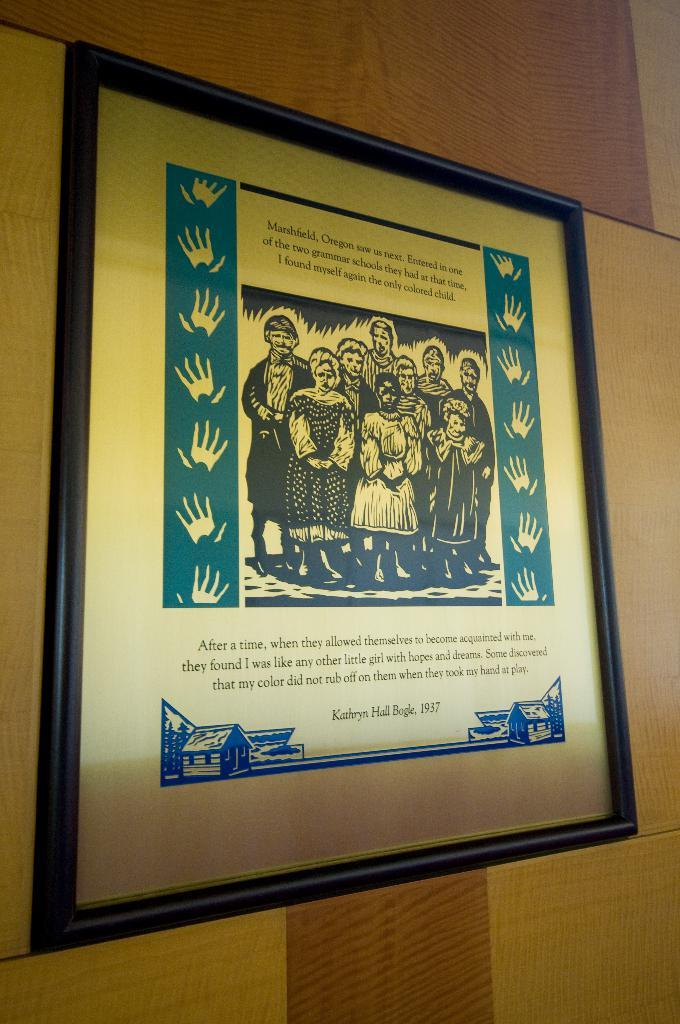Provide a one-sentence caption for the provided image. A framed drawing of people including Kathryn Hail Beagle from 1937. 